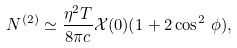Convert formula to latex. <formula><loc_0><loc_0><loc_500><loc_500>N ^ { ( 2 ) } \simeq \frac { \eta ^ { 2 } T } { 8 \pi c } \mathcal { X } ( 0 ) ( 1 + 2 \cos ^ { 2 } \, \phi ) ,</formula> 